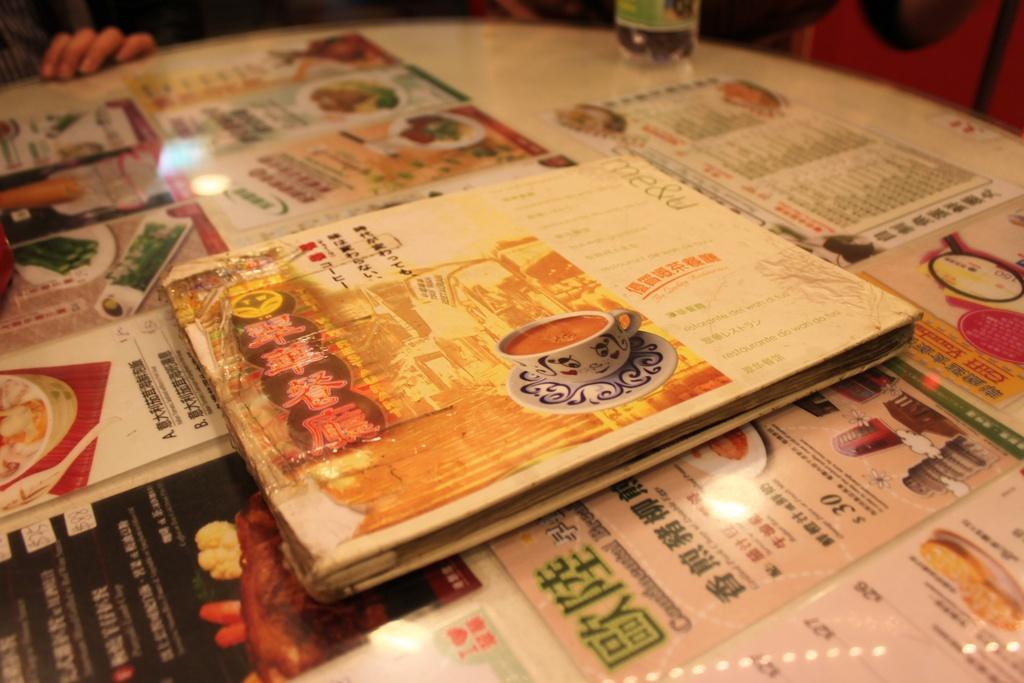<image>
Share a concise interpretation of the image provided. A variety of foreign menus including items do wah do tuni and others. 